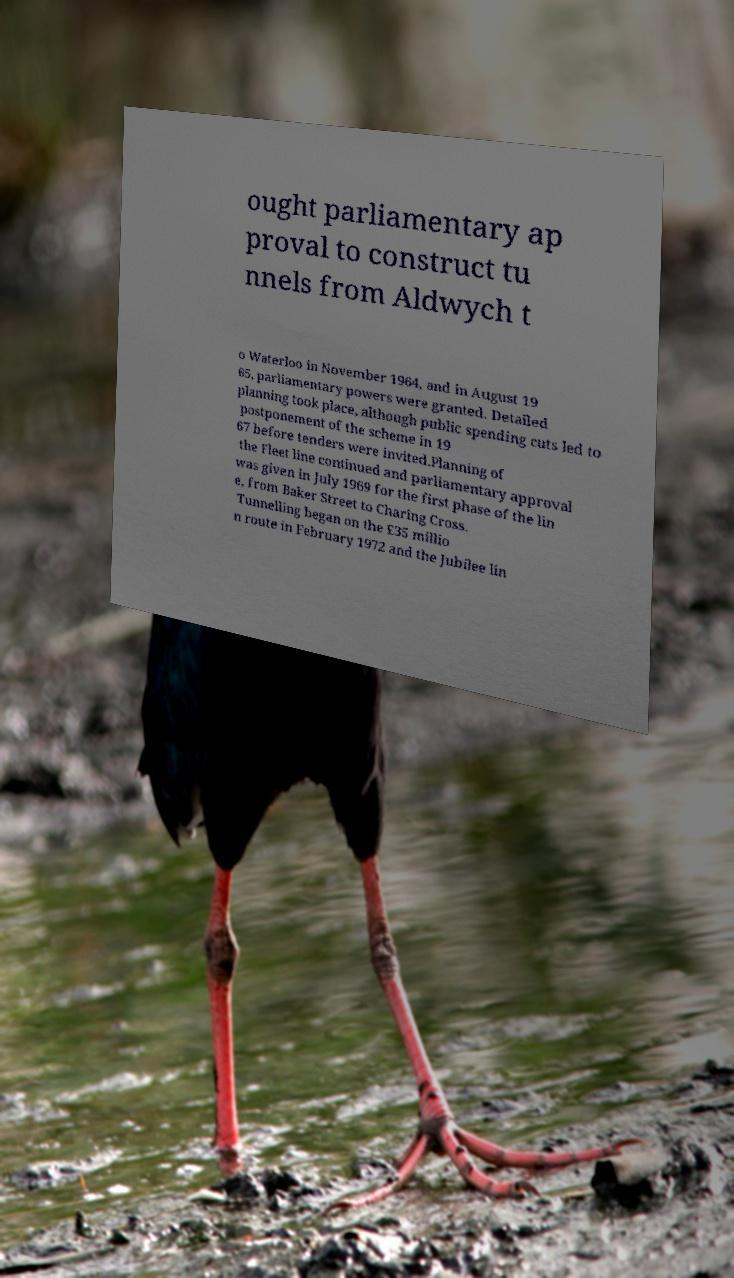Please identify and transcribe the text found in this image. ought parliamentary ap proval to construct tu nnels from Aldwych t o Waterloo in November 1964, and in August 19 65, parliamentary powers were granted. Detailed planning took place, although public spending cuts led to postponement of the scheme in 19 67 before tenders were invited.Planning of the Fleet line continued and parliamentary approval was given in July 1969 for the first phase of the lin e, from Baker Street to Charing Cross. Tunnelling began on the £35 millio n route in February 1972 and the Jubilee lin 